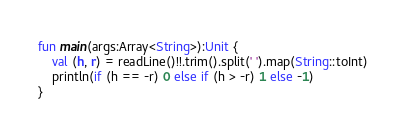Convert code to text. <code><loc_0><loc_0><loc_500><loc_500><_Kotlin_>
fun main(args:Array<String>):Unit {
    val (h, r) = readLine()!!.trim().split(' ').map(String::toInt)
    println(if (h == -r) 0 else if (h > -r) 1 else -1)
}
</code> 